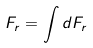<formula> <loc_0><loc_0><loc_500><loc_500>F _ { r } = \int d F _ { r }</formula> 